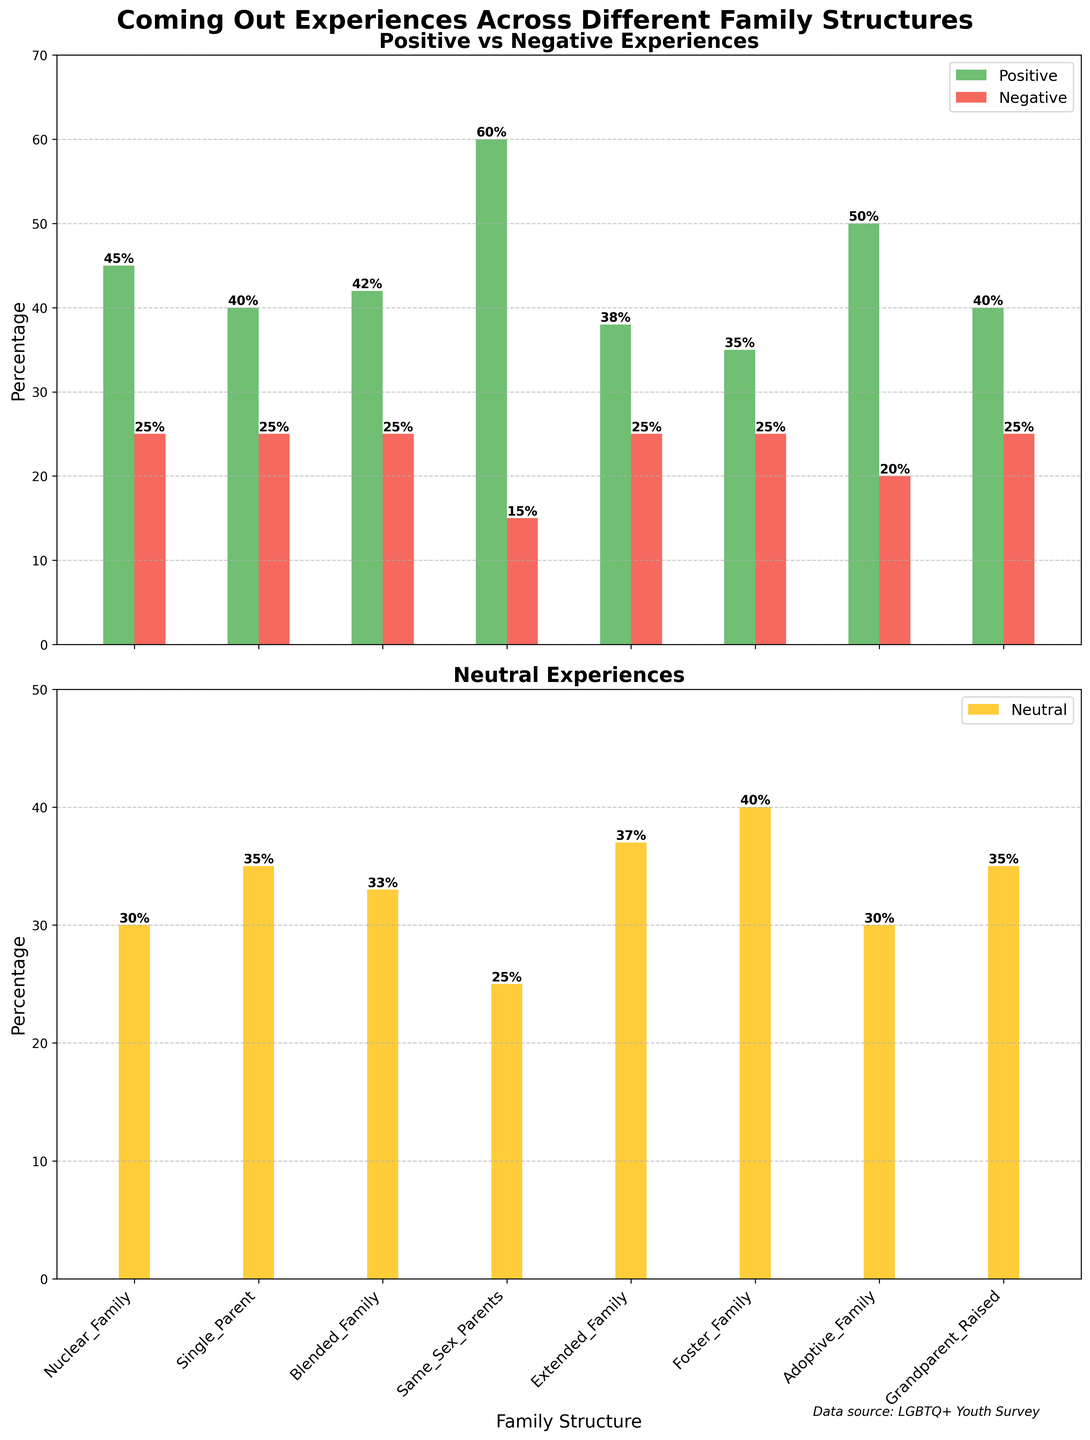Which family structure has the highest percentage of positive coming out experiences? The bar for positive experiences is highest for the category "Same Sex Parents," reaching up to 60%.
Answer: Same Sex Parents Which family structure sees the lowest percentage of negative coming out experiences? The bar for negative experiences is lowest for the "Same Sex Parents" category, with a percentage of 15%.
Answer: Same Sex Parents What is the combined percentage of positive and negative experiences for those raised in nuclear families? For the "Nuclear Family" category, the positive is 45% and the negative is 25%. Adding them, 45% + 25% = 70%.
Answer: 70% Which family structure has the highest percentage of neutral coming out experiences? The highest bar in the neutral experiences plot is seen for "Foster Family" with a percentage of 40%.
Answer: Foster Family Compare the percentage of positive experiences for those raised in adoptive families versus those raised in extended families. Which is higher? The "Adoptive Family" category shows a positive experience percentage of 50%, while the "Extended Family" category shows 38%. Therefore, Adoptive Family is higher.
Answer: Adoptive Family What is the difference between the highest and lowest positive experience percentages across all family structures? The highest positive experience is 60% (Same Sex Parents) and the lowest is 35% (Foster Family). The difference is 60% - 35% = 25%.
Answer: 25% Which family structure has the equal percentage of positive and negative coming out experiences? "Single Parent," "Blended Family," "Extended Family," "Foster Family," and "Grandparent Raised" all have 25% negative experiences and varying positive experiences, but none of them have equal values for both. Upon further inspection, none match the criteria exactly.
Answer: None How many family structures have neutral experiences percentages equal or higher than 35%? The family structures with neutral experiences ≥ 35% are "Single Parent" (35%), "Blended Family" (33%), "Extended Family" (37%), "Foster Family" (40%), and "Grandparent Raised" (35%). That's a total of 5.
Answer: 5 